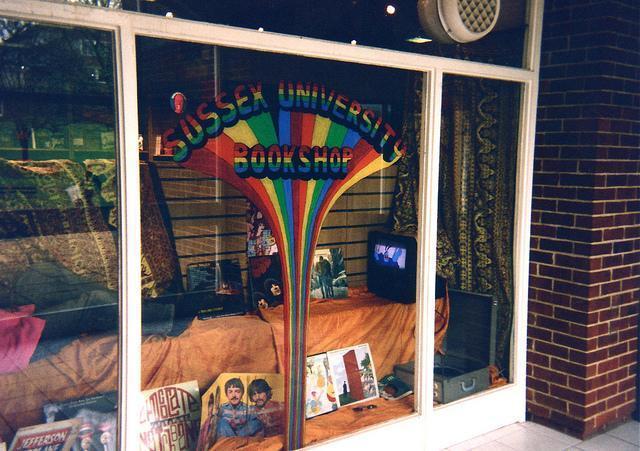How many tvs can you see?
Give a very brief answer. 1. 